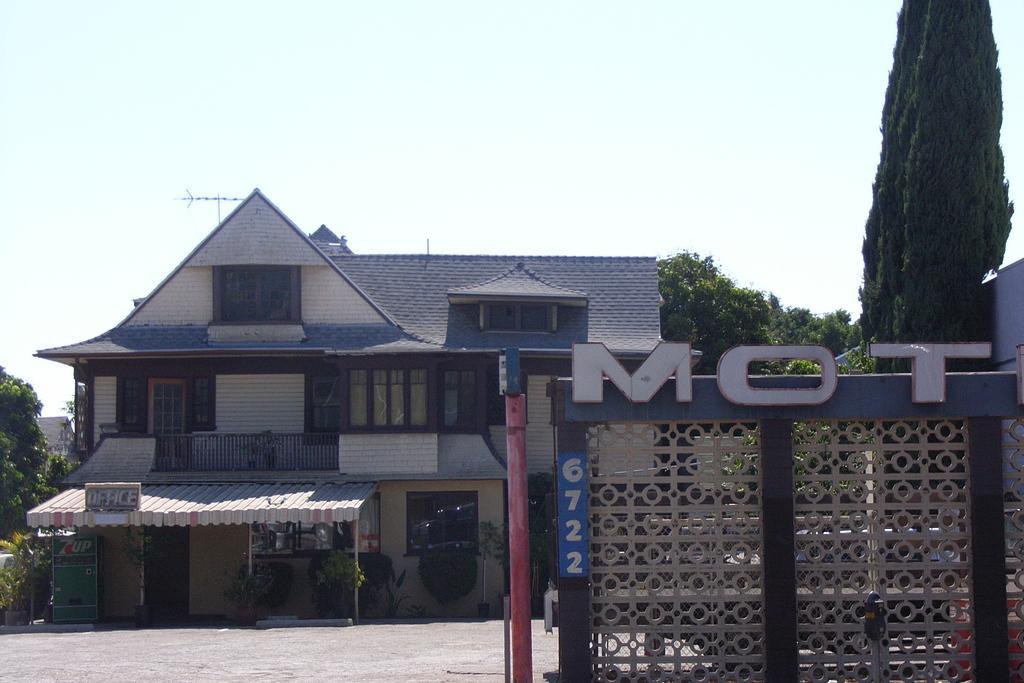Describe this image in one or two sentences. In this image we can see a few buildings, there are some trees, poles, plants, windows and boards, also we can see an object which looks like the wall, on the wall we can see some text, in the background, we can see the sky. 